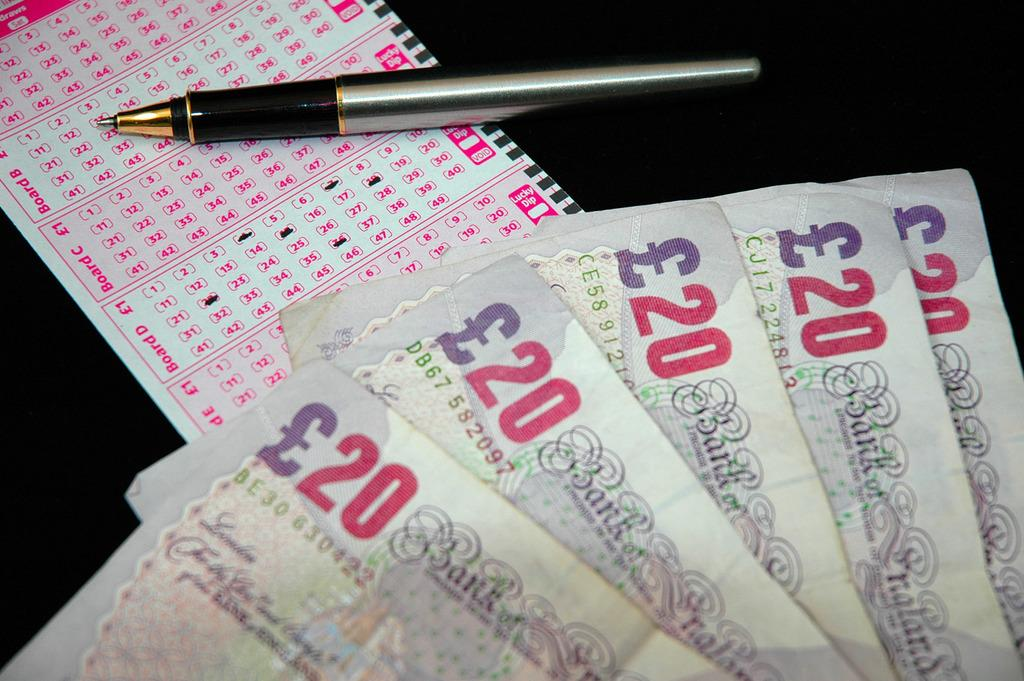How many notes are present in the image? There are five notes in the image. What writing instrument is visible in the image? There is a pen in the image. What type of paper is present in the image? There is an omr sheet in the image. What is the color of the surface on which the objects are placed? The objects are on a black surface. What type of nerve is visible in the image? There is no nerve present in the image; it only contains notes, a pen, an omr sheet, and a black surface. What kind of meal is being prepared in the image? There is no meal preparation or food present in the image. 